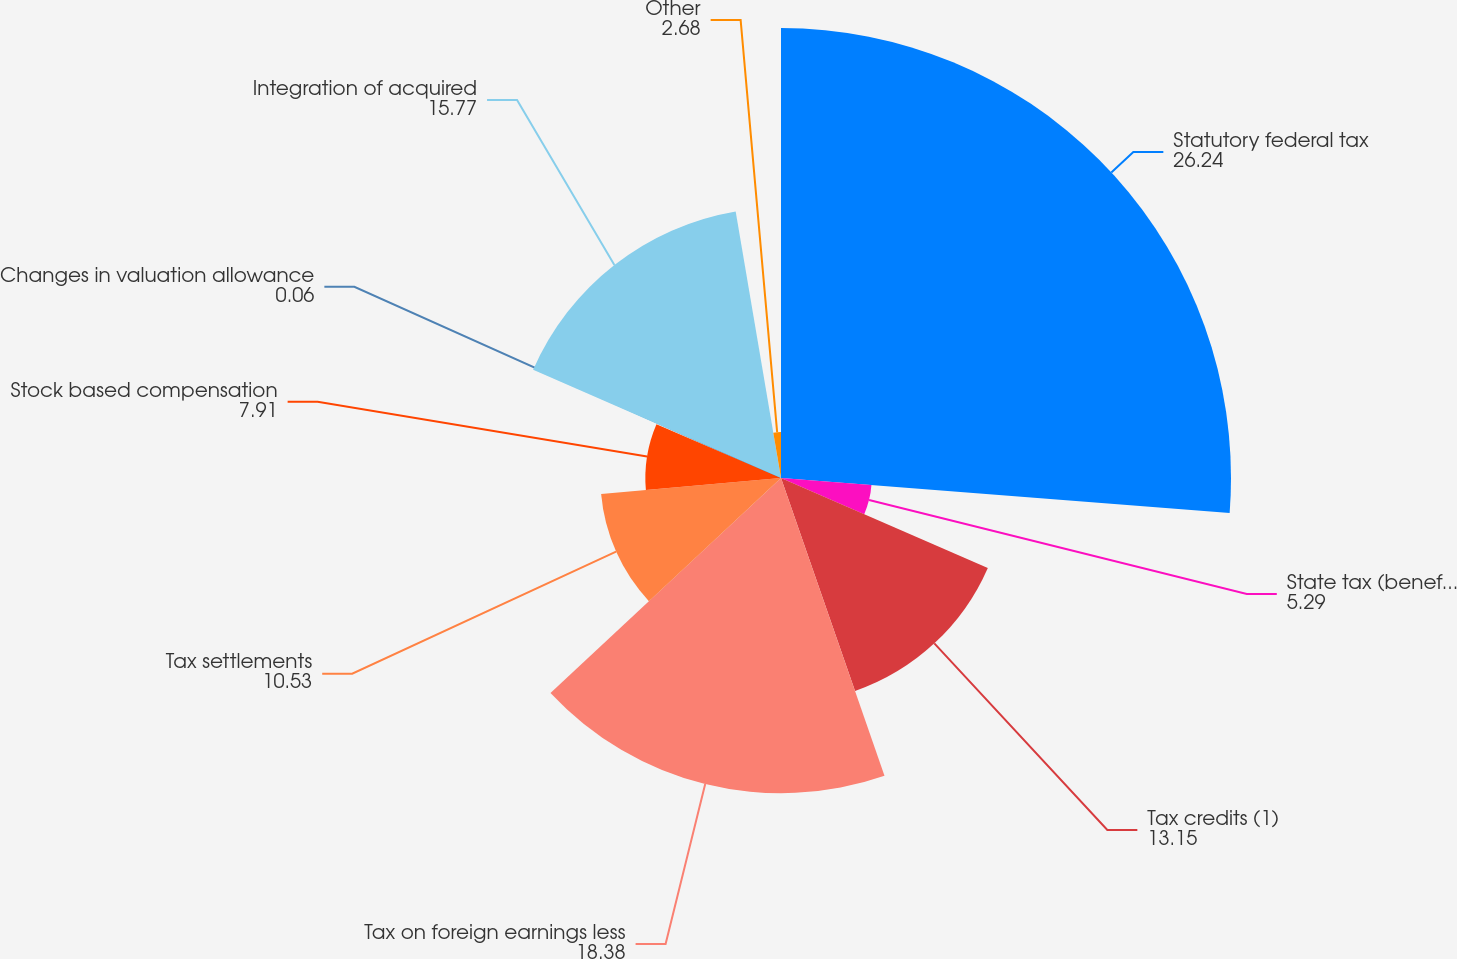Convert chart to OTSL. <chart><loc_0><loc_0><loc_500><loc_500><pie_chart><fcel>Statutory federal tax<fcel>State tax (benefit) net of<fcel>Tax credits (1)<fcel>Tax on foreign earnings less<fcel>Tax settlements<fcel>Stock based compensation<fcel>Changes in valuation allowance<fcel>Integration of acquired<fcel>Other<nl><fcel>26.24%<fcel>5.29%<fcel>13.15%<fcel>18.38%<fcel>10.53%<fcel>7.91%<fcel>0.06%<fcel>15.77%<fcel>2.68%<nl></chart> 